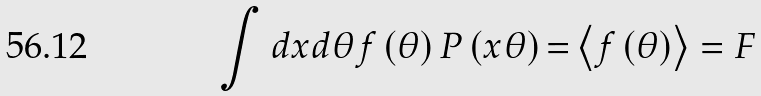Convert formula to latex. <formula><loc_0><loc_0><loc_500><loc_500>\int d x d \theta f \left ( \theta \right ) P \left ( x \theta \right ) { = } \left \langle f \left ( \theta \right ) \right \rangle = F</formula> 